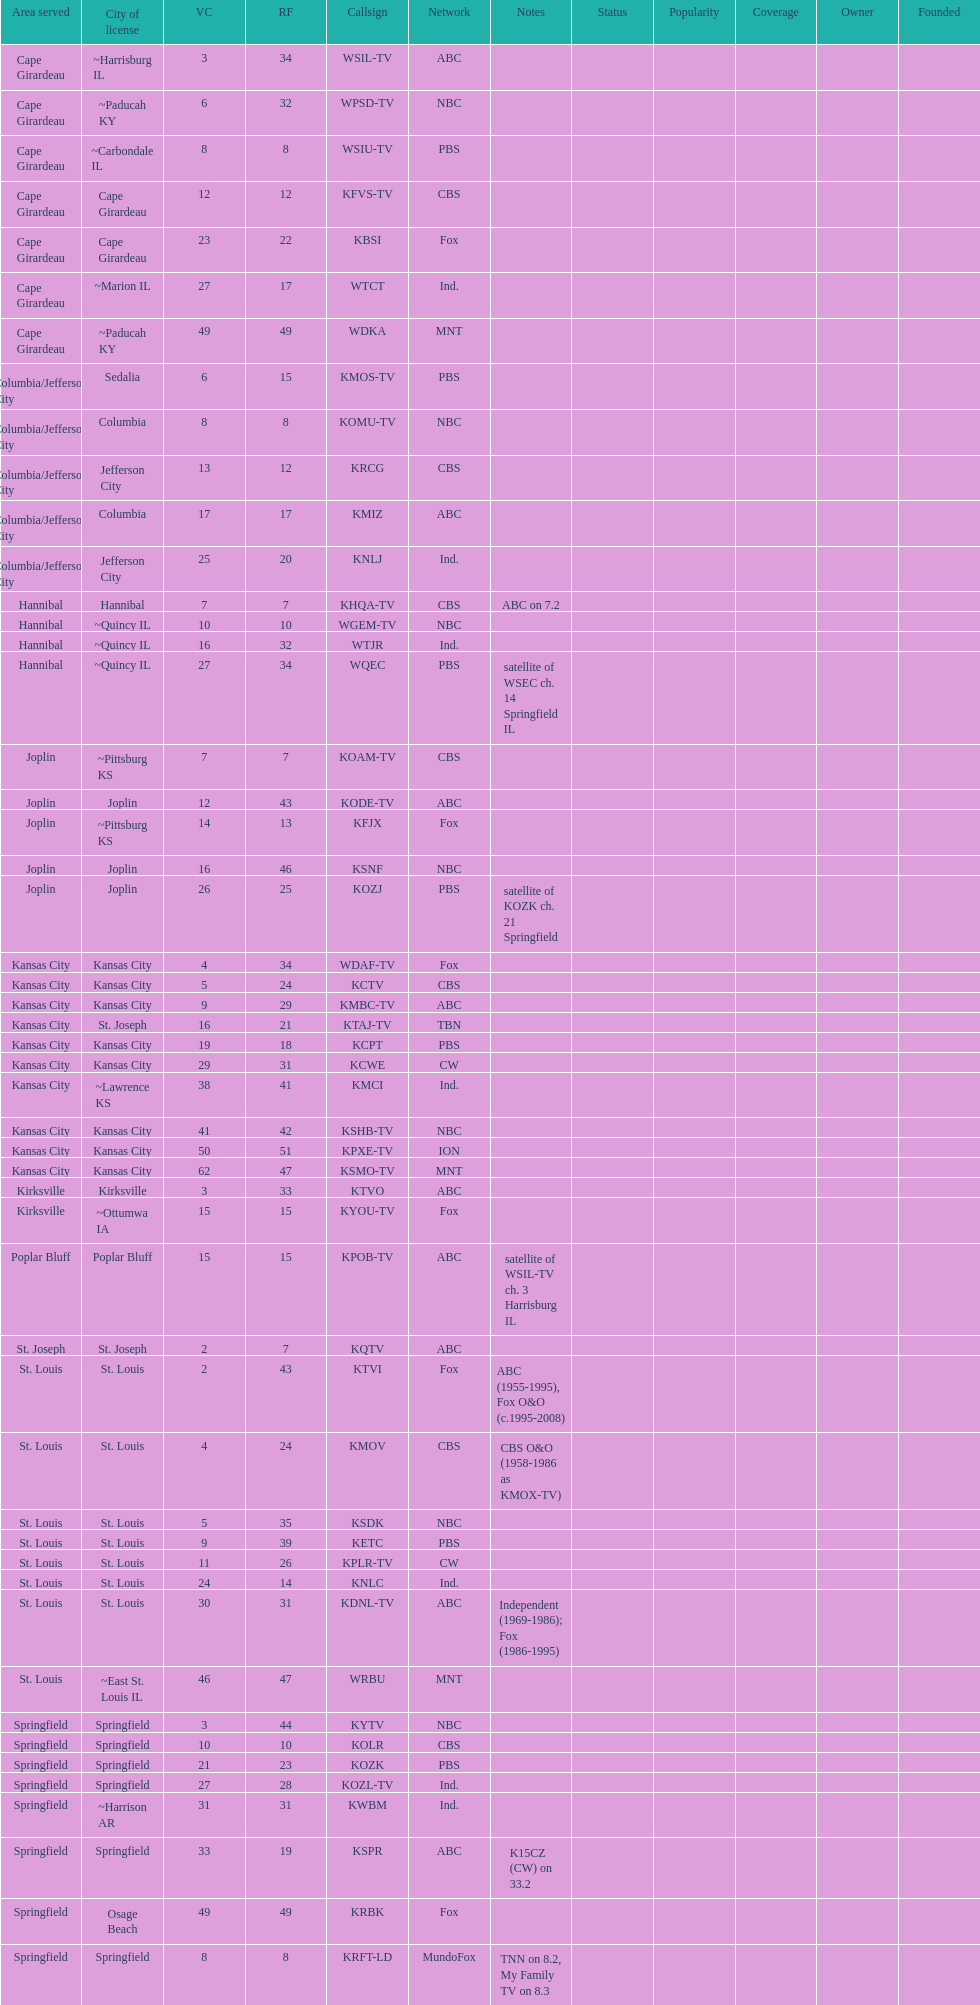Which station is licensed in the same city as koam-tv? KFJX. 